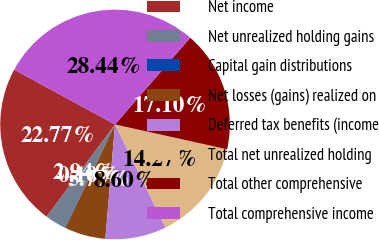<chart> <loc_0><loc_0><loc_500><loc_500><pie_chart><fcel>Net income<fcel>Net unrealized holding gains<fcel>Capital gain distributions<fcel>Net losses (gains) realized on<fcel>Deferred tax benefits (income<fcel>Total net unrealized holding<fcel>Total other comprehensive<fcel>Total comprehensive income<nl><fcel>22.77%<fcel>2.94%<fcel>0.1%<fcel>5.77%<fcel>8.6%<fcel>14.27%<fcel>17.1%<fcel>28.44%<nl></chart> 